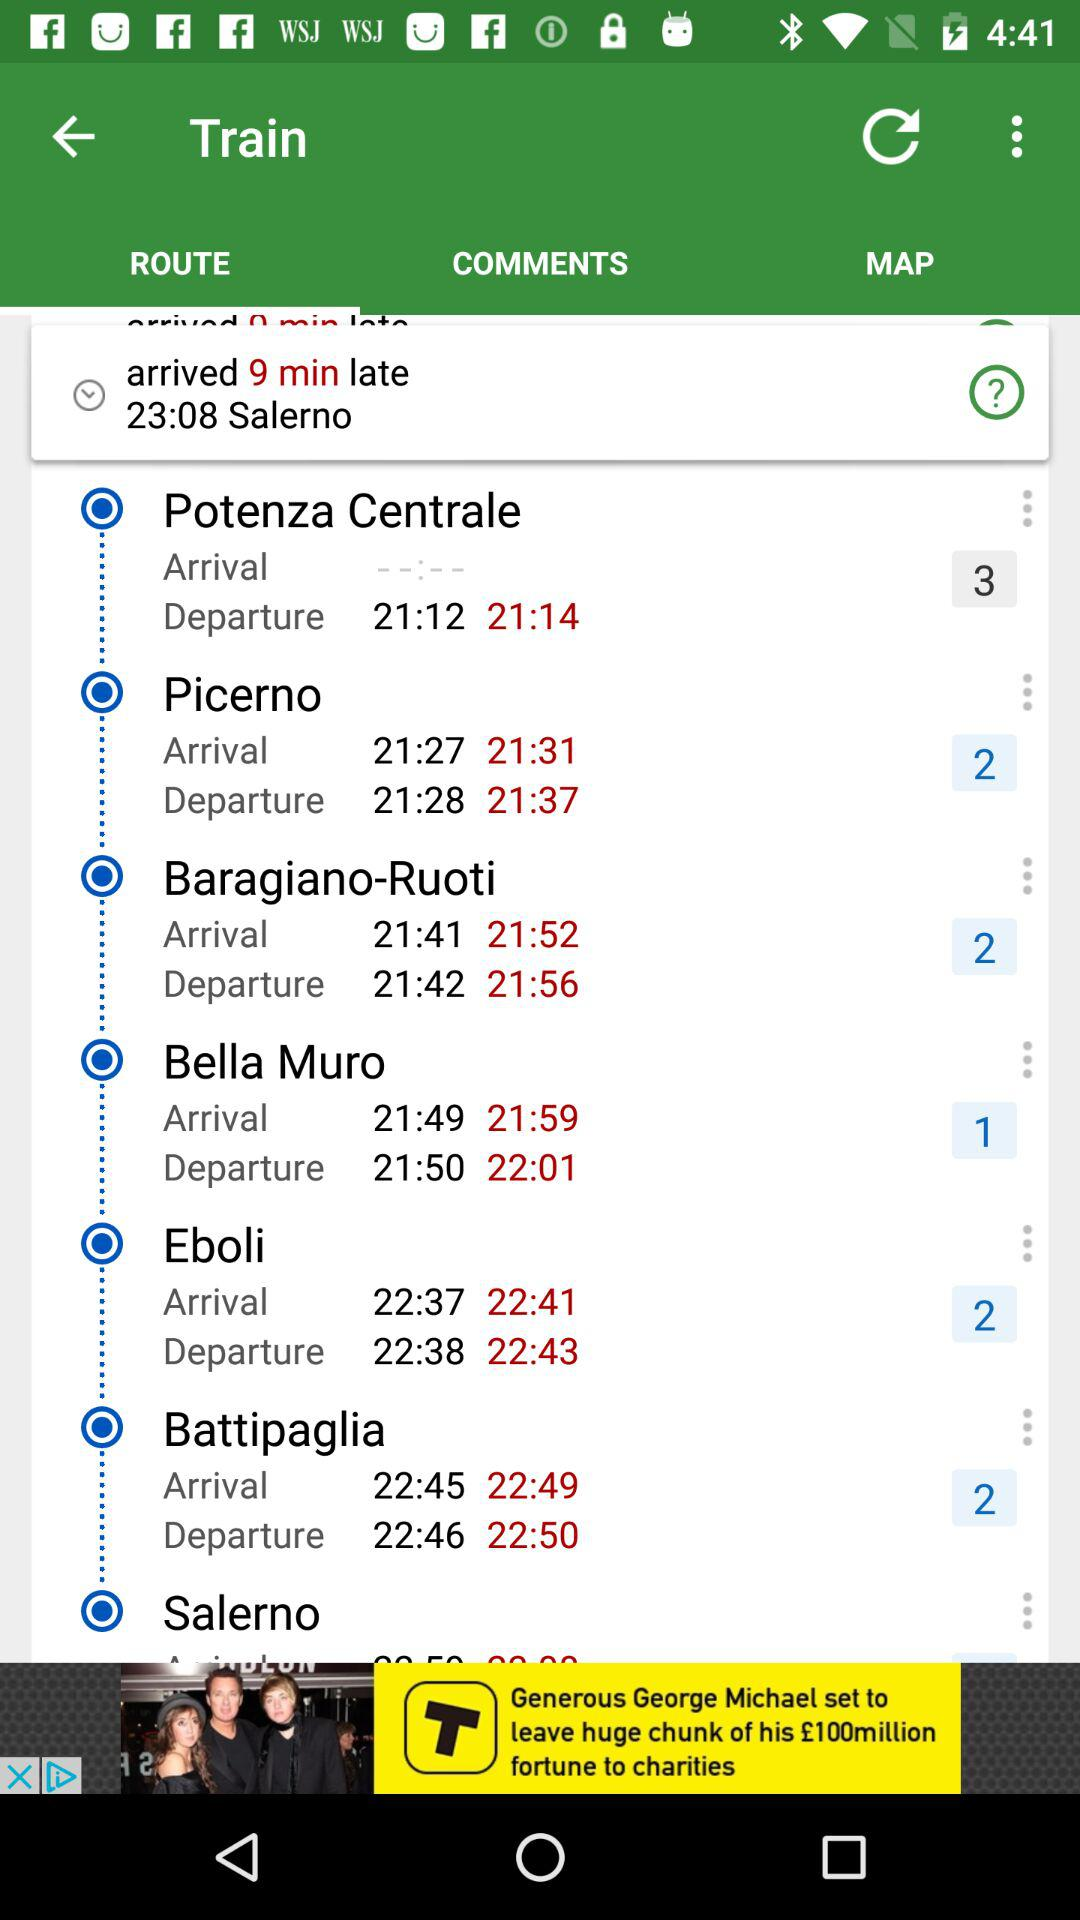What is the expected time of train arrival at "Eboli"? The expected time of train arrival at "Eboli" is 22:37. 